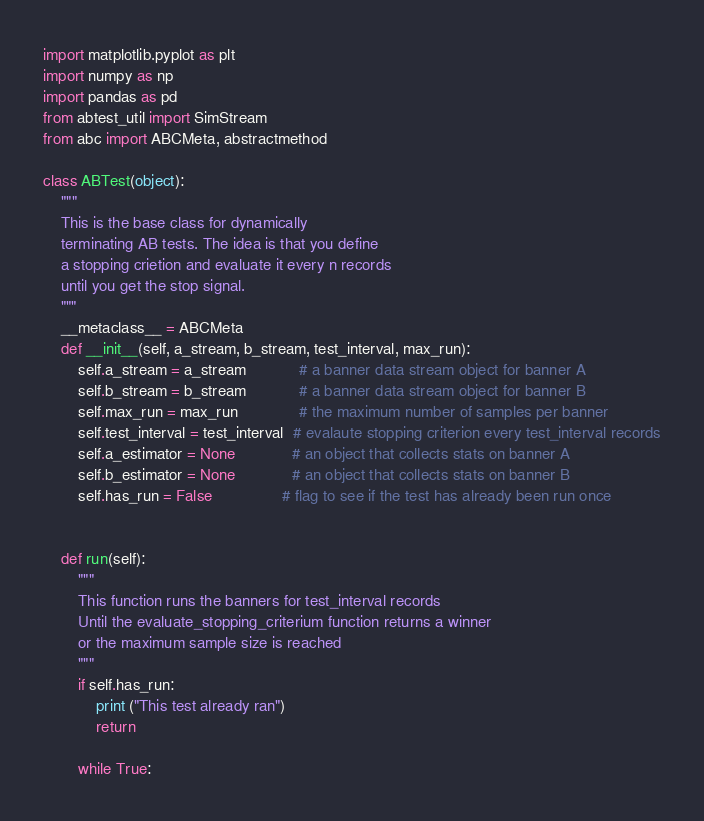Convert code to text. <code><loc_0><loc_0><loc_500><loc_500><_Python_>import matplotlib.pyplot as plt
import numpy as np
import pandas as pd
from abtest_util import SimStream
from abc import ABCMeta, abstractmethod

class ABTest(object):
    """
    This is the base class for dynamically
    terminating AB tests. The idea is that you define
    a stopping crietion and evaluate it every n records
    until you get the stop signal.
    """
    __metaclass__ = ABCMeta
    def __init__(self, a_stream, b_stream, test_interval, max_run):
        self.a_stream = a_stream            # a banner data stream object for banner A
        self.b_stream = b_stream            # a banner data stream object for banner B
        self.max_run = max_run              # the maximum number of samples per banner
        self.test_interval = test_interval  # evalaute stopping criterion every test_interval records
        self.a_estimator = None             # an object that collects stats on banner A
        self.b_estimator = None             # an object that collects stats on banner B
        self.has_run = False                # flag to see if the test has already been run once


    def run(self):
        """
        This function runs the banners for test_interval records
        Until the evaluate_stopping_criterium function returns a winner
        or the maximum sample size is reached 
        """
        if self.has_run:
            print ("This test already ran")
            return

        while True:</code> 